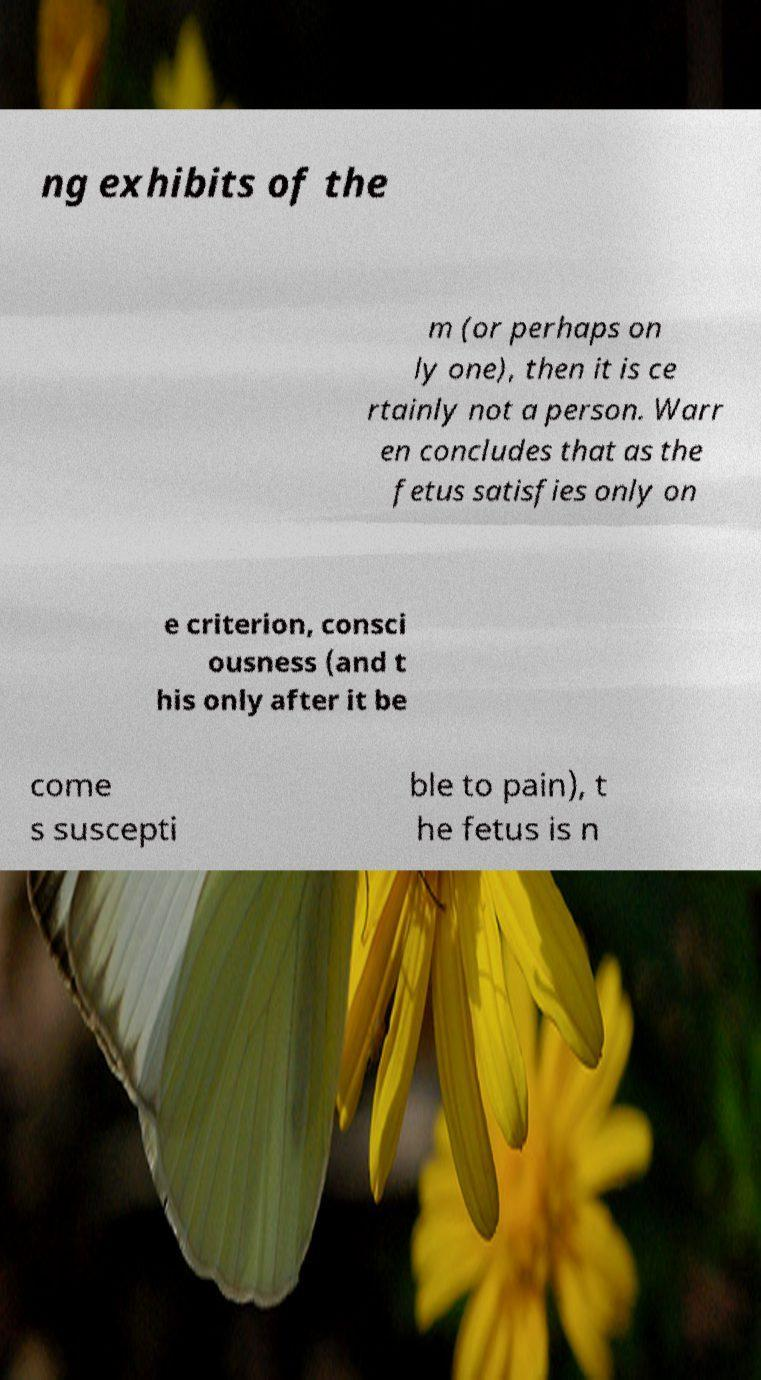Could you extract and type out the text from this image? ng exhibits of the m (or perhaps on ly one), then it is ce rtainly not a person. Warr en concludes that as the fetus satisfies only on e criterion, consci ousness (and t his only after it be come s suscepti ble to pain), t he fetus is n 